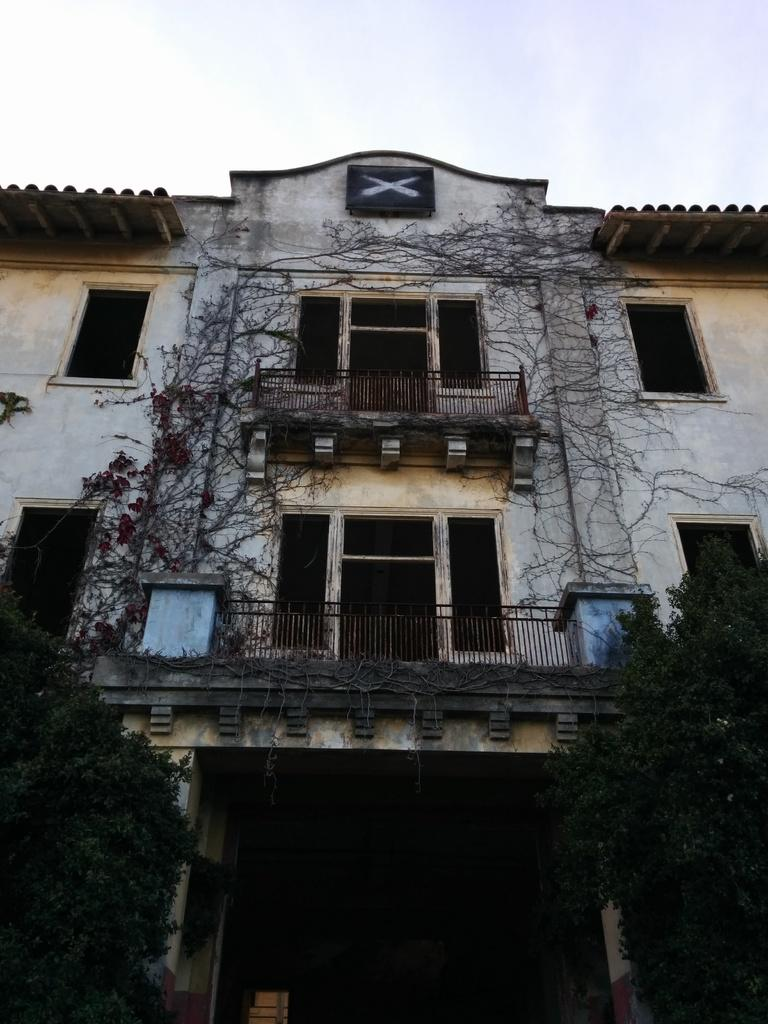What type of structure can be seen in the image? There is a building in the image. What type of vegetation is present in the image? Creepers and trees are visible in the image. What type of barrier is present in the image? Iron grills are visible in the image. What type of shelter is present in the image? There is a shed in the image. What part of the natural environment is visible in the image? The sky is visible in the image. What type of truck can be seen driving through the building in the image? There is no truck present in the image, and the building is not being driven through. 